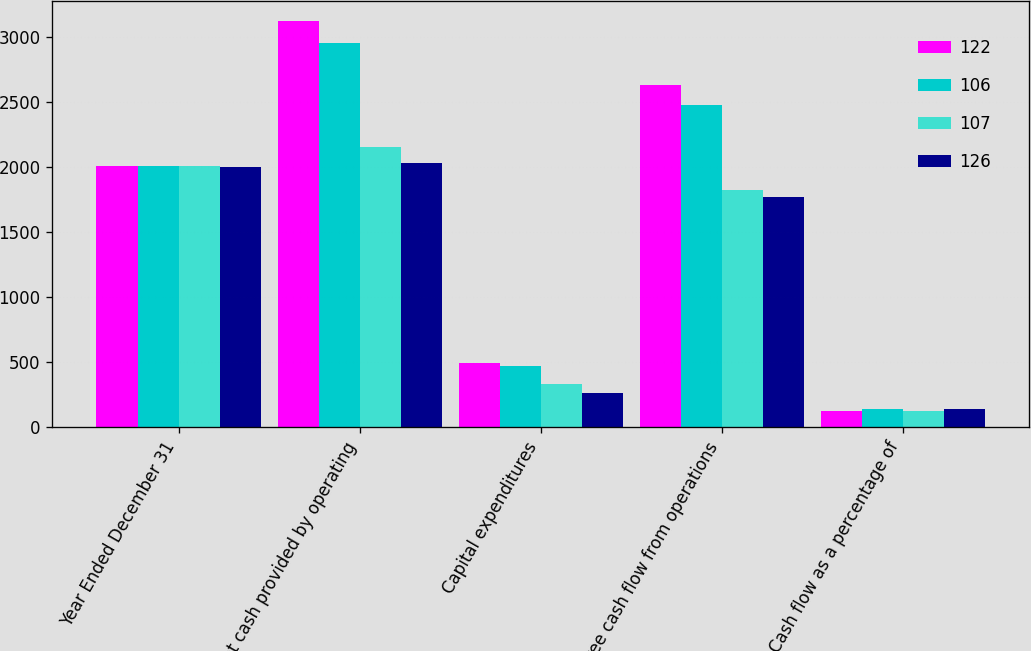Convert chart to OTSL. <chart><loc_0><loc_0><loc_500><loc_500><stacked_bar_chart><ecel><fcel>Year Ended December 31<fcel>Net cash provided by operating<fcel>Capital expenditures<fcel>Free cash flow from operations<fcel>Cash flow as a percentage of<nl><fcel>122<fcel>2008<fcel>3124<fcel>490<fcel>2634<fcel>126<nl><fcel>106<fcel>2007<fcel>2952<fcel>474<fcel>2478<fcel>142<nl><fcel>107<fcel>2006<fcel>2156<fcel>334<fcel>1822<fcel>126<nl><fcel>126<fcel>2005<fcel>2033<fcel>262<fcel>1771<fcel>140<nl></chart> 